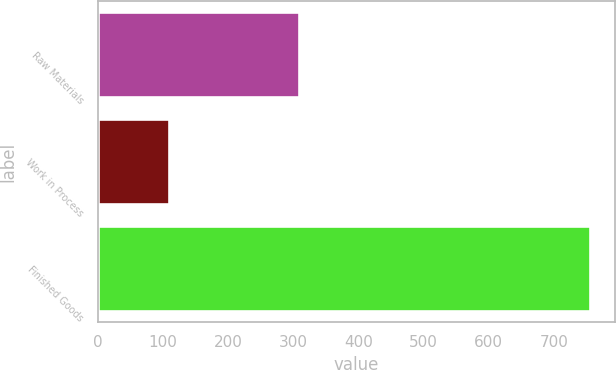Convert chart. <chart><loc_0><loc_0><loc_500><loc_500><bar_chart><fcel>Raw Materials<fcel>Work in Process<fcel>Finished Goods<nl><fcel>309.2<fcel>108.4<fcel>755.3<nl></chart> 